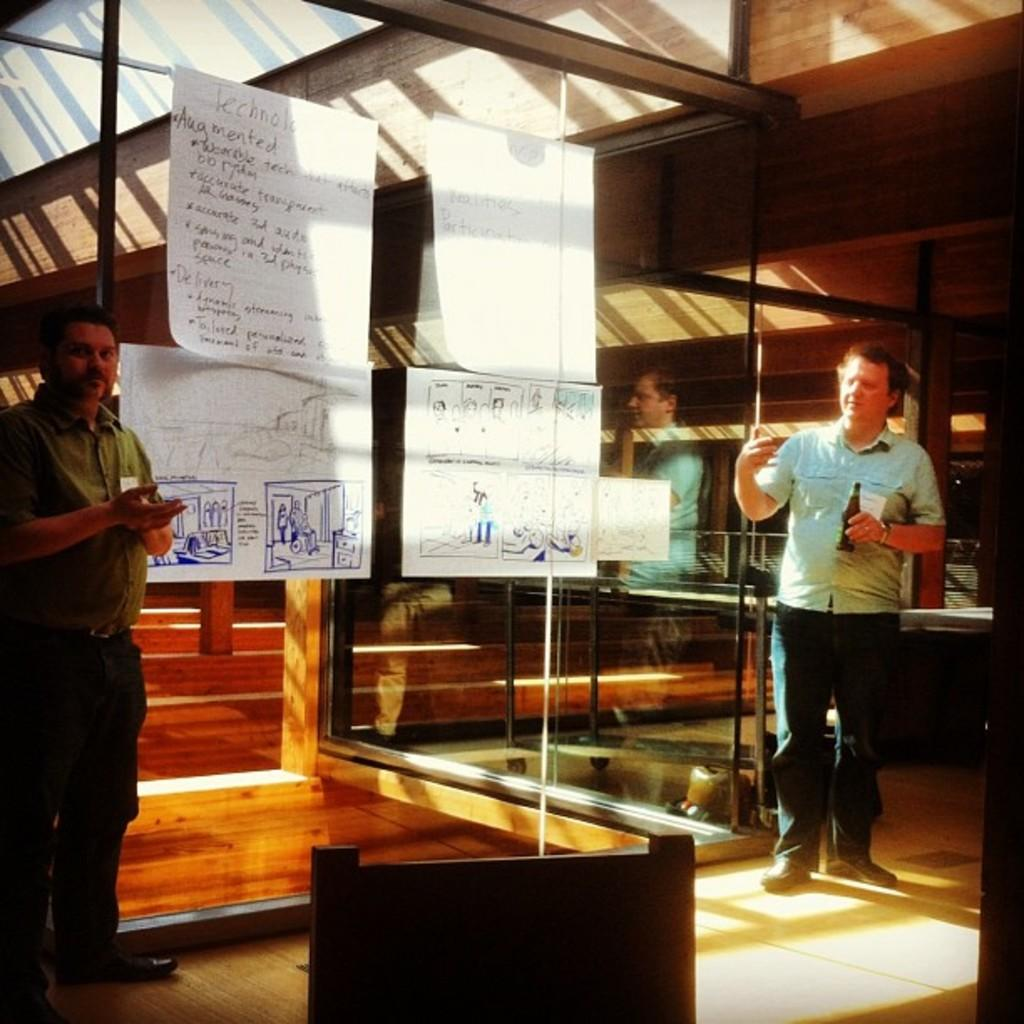How many people are in the image? There are persons standing in the image. What are the people wearing? The persons are wearing clothes. What can be seen on the glass wall in the image? There are charts on a glass wall in the image. What is located at the bottom of the image? There is an object at the bottom of the image. What type of oven is being used by the mother in the image? There is no mother or oven present in the image. How many fingers does the person on the left have in the image? The number of fingers cannot be determined from the image, as it does not show the person's hands. 